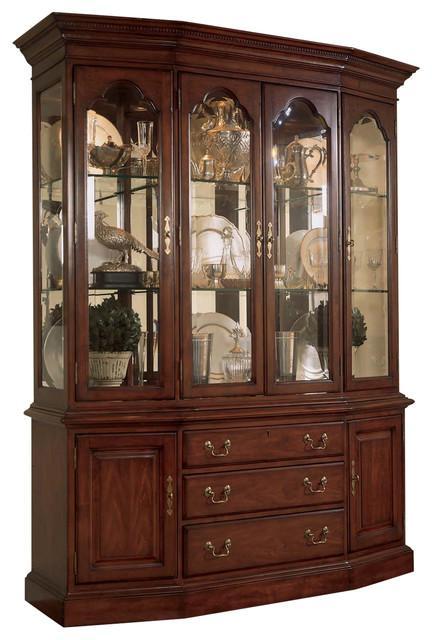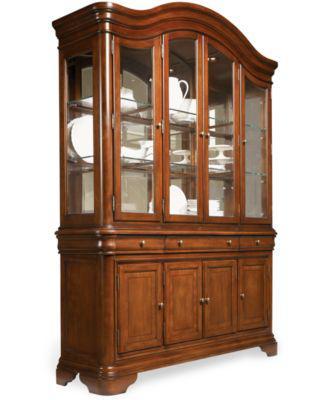The first image is the image on the left, the second image is the image on the right. Considering the images on both sides, is "One of the cabinet fronts is not flat across the top." valid? Answer yes or no. Yes. 